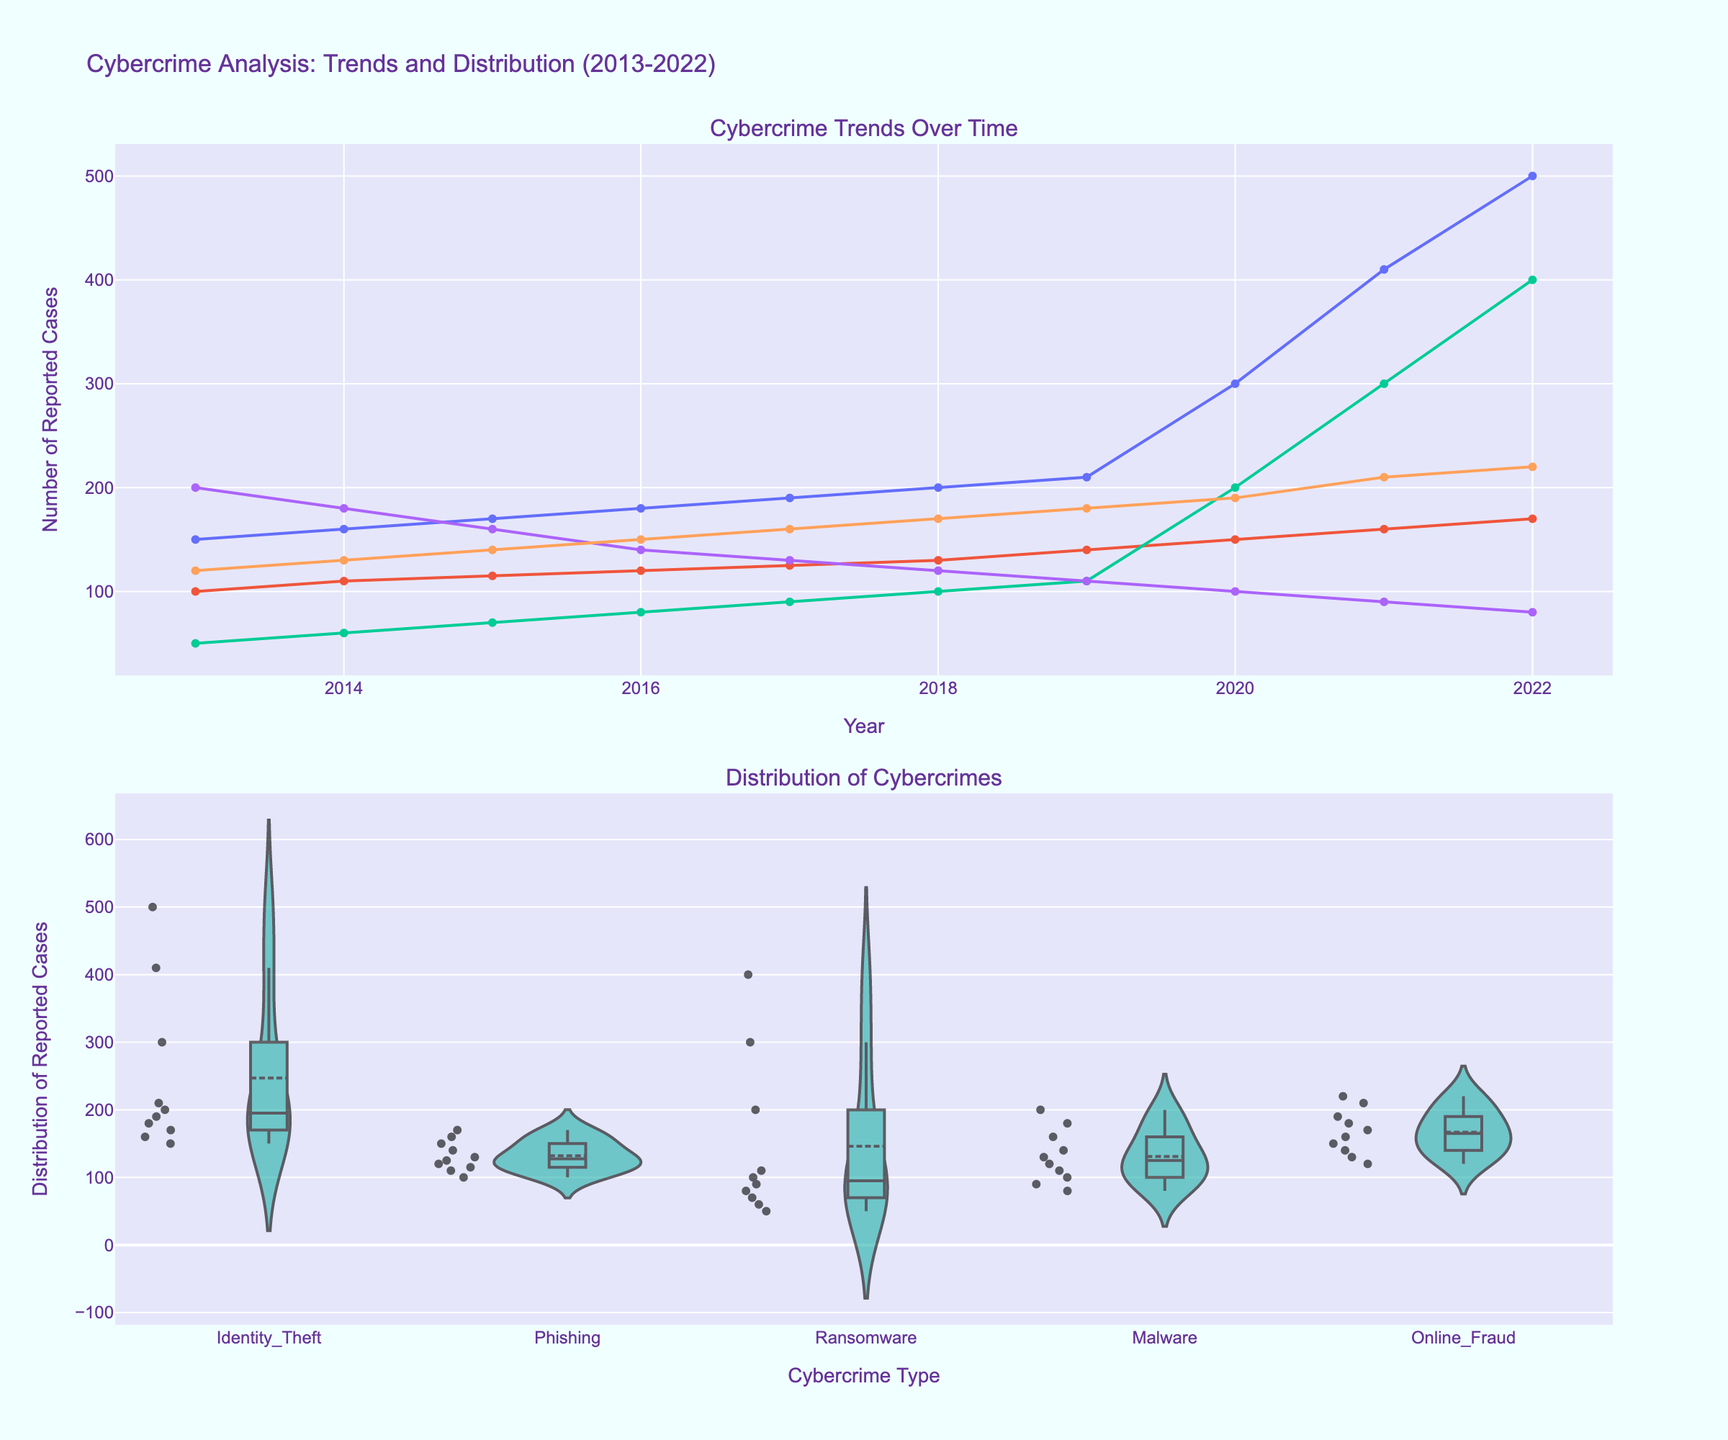What's the general trend of identity theft over the last decade? The line plot shows an increasing trend for identity theft incidents over the years, peaking at 500 cases in 2022. By observing the values, it can be seen that identity theft cases have been on the rise, especially from 2020 onwards.
Answer: Increasing trend Which type of cybercrime had the highest number of reported cases in 2022? By looking at the line plot for 2022, identity theft had the highest number of reported cases compared to other cybercrimes, with 500 cases.
Answer: Identity theft How do the reported cases of malware change over the years? The line plot indicates that the number of malware cases decreases over the years, starting from 200 in 2013 to 80 in 2022.
Answer: Decrease What can be inferred about the distribution of ransomware cases? The violin plot shows that ransomware cases have a wide distribution with most of the values in the lower range but also many outlier cases, especially in recent years like 2021 and 2022.
Answer: Wide distribution with outliers Which type of cybercrime has the smallest range in the distribution of reported cases? Online fraud appears to have the smallest range in its distribution according to the violin plot, as the cases range from about 120 to 220 without significant outliers.
Answer: Online fraud What's the median number of reported cases for phishing? From the violin plot, the box indicates the central distribution of phishing cases. The median falls in the middle of the box, which corresponds to around 125 cases.
Answer: 125 cases Between identity theft and ransomware, which showed a more rapid increase from 2020 to 2022? By comparing the slopes of the lines for identity theft and ransomware from 2020 to 2022, identity theft shows a steeper increase (from 300 to 500) compared to ransomware (from 200 to 400).
Answer: Identity theft What's the average number of reported cases over the decade for online fraud? Summation of cases for online fraud from 2013 to 2022 (120+130+140+150+160+170+180+190+210+220) equals 1670. Dividing this by 10 gives an average of 167.
Answer: 167 cases 